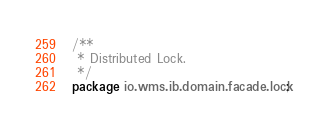<code> <loc_0><loc_0><loc_500><loc_500><_Java_>/**
 * Distributed Lock.
 */
package io.wms.ib.domain.facade.lock;
</code> 